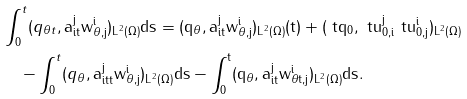Convert formula to latex. <formula><loc_0><loc_0><loc_500><loc_500>& \int _ { 0 } ^ { t } ( q _ { \theta t } , \tt a _ { i t } ^ { j } w _ { \theta , j } ^ { i } ) _ { L ^ { 2 } ( \Omega ) } d s = ( q _ { \theta } , \tt a _ { i t } ^ { j } w _ { \theta , j } ^ { i } ) _ { L ^ { 2 } ( \Omega ) } ( t ) + ( \ t q _ { 0 } , \ t u _ { 0 , i } ^ { j } \ t u _ { 0 , j } ^ { i } ) _ { L ^ { 2 } ( \Omega ) } \\ & \quad - \int _ { 0 } ^ { t } ( q _ { \theta } , \tt a _ { i t t } ^ { j } w _ { \theta , j } ^ { i } ) _ { L ^ { 2 } ( \Omega ) } d s - \int _ { 0 } ^ { t } ( q _ { \theta } , \tt a _ { i t } ^ { j } w _ { \theta t , j } ^ { i } ) _ { L ^ { 2 } ( \Omega ) } d s .</formula> 